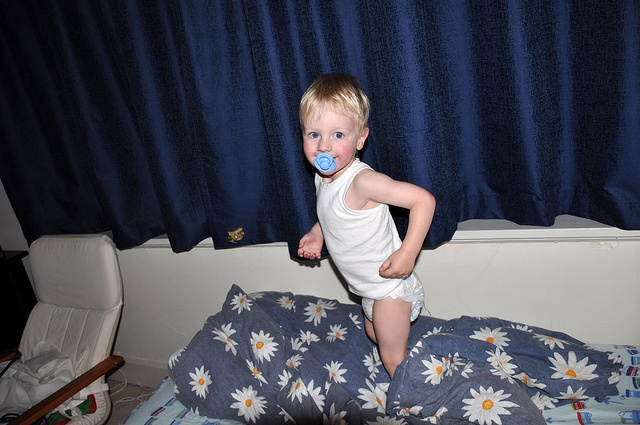Describe the objects in this image and their specific colors. I can see bed in black, gray, darkgray, and darkblue tones, people in black, lightgray, lightpink, and darkgray tones, and chair in black, gray, and maroon tones in this image. 